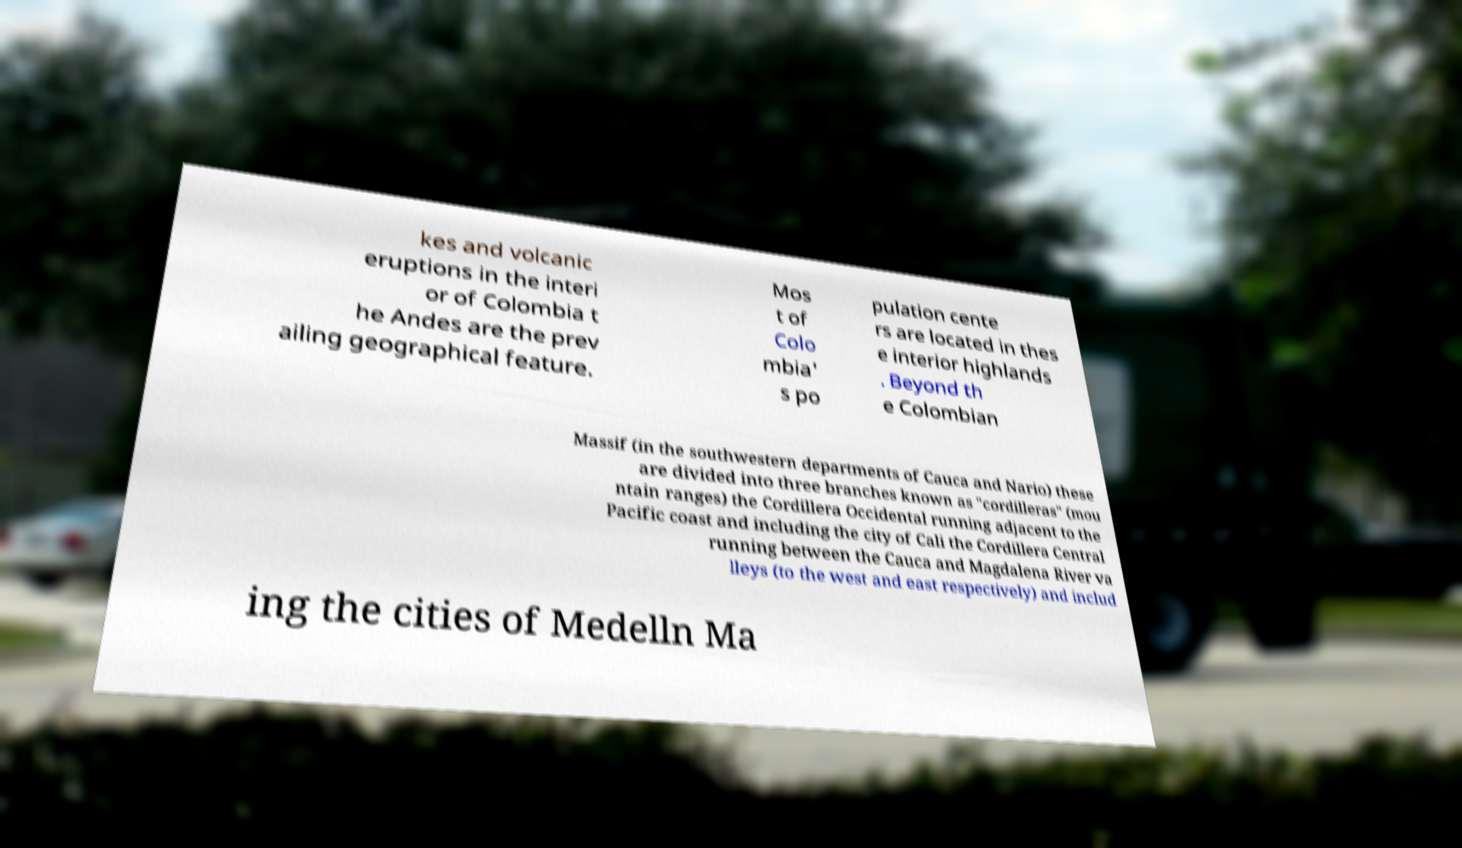Please read and relay the text visible in this image. What does it say? kes and volcanic eruptions in the interi or of Colombia t he Andes are the prev ailing geographical feature. Mos t of Colo mbia' s po pulation cente rs are located in thes e interior highlands . Beyond th e Colombian Massif (in the southwestern departments of Cauca and Nario) these are divided into three branches known as "cordilleras" (mou ntain ranges) the Cordillera Occidental running adjacent to the Pacific coast and including the city of Cali the Cordillera Central running between the Cauca and Magdalena River va lleys (to the west and east respectively) and includ ing the cities of Medelln Ma 